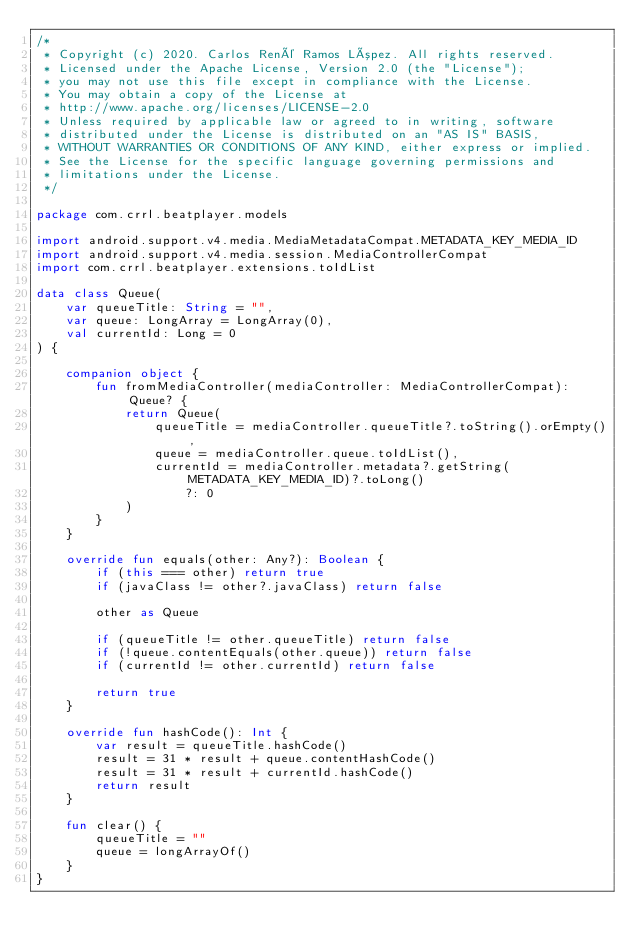Convert code to text. <code><loc_0><loc_0><loc_500><loc_500><_Kotlin_>/*
 * Copyright (c) 2020. Carlos René Ramos López. All rights reserved.
 * Licensed under the Apache License, Version 2.0 (the "License");
 * you may not use this file except in compliance with the License.
 * You may obtain a copy of the License at
 * http://www.apache.org/licenses/LICENSE-2.0
 * Unless required by applicable law or agreed to in writing, software
 * distributed under the License is distributed on an "AS IS" BASIS,
 * WITHOUT WARRANTIES OR CONDITIONS OF ANY KIND, either express or implied.
 * See the License for the specific language governing permissions and
 * limitations under the License.
 */

package com.crrl.beatplayer.models

import android.support.v4.media.MediaMetadataCompat.METADATA_KEY_MEDIA_ID
import android.support.v4.media.session.MediaControllerCompat
import com.crrl.beatplayer.extensions.toIdList

data class Queue(
    var queueTitle: String = "",
    var queue: LongArray = LongArray(0),
    val currentId: Long = 0
) {

    companion object {
        fun fromMediaController(mediaController: MediaControllerCompat): Queue? {
            return Queue(
                queueTitle = mediaController.queueTitle?.toString().orEmpty(),
                queue = mediaController.queue.toIdList(),
                currentId = mediaController.metadata?.getString(METADATA_KEY_MEDIA_ID)?.toLong()
                    ?: 0
            )
        }
    }

    override fun equals(other: Any?): Boolean {
        if (this === other) return true
        if (javaClass != other?.javaClass) return false

        other as Queue

        if (queueTitle != other.queueTitle) return false
        if (!queue.contentEquals(other.queue)) return false
        if (currentId != other.currentId) return false

        return true
    }

    override fun hashCode(): Int {
        var result = queueTitle.hashCode()
        result = 31 * result + queue.contentHashCode()
        result = 31 * result + currentId.hashCode()
        return result
    }

    fun clear() {
        queueTitle = ""
        queue = longArrayOf()
    }
}</code> 